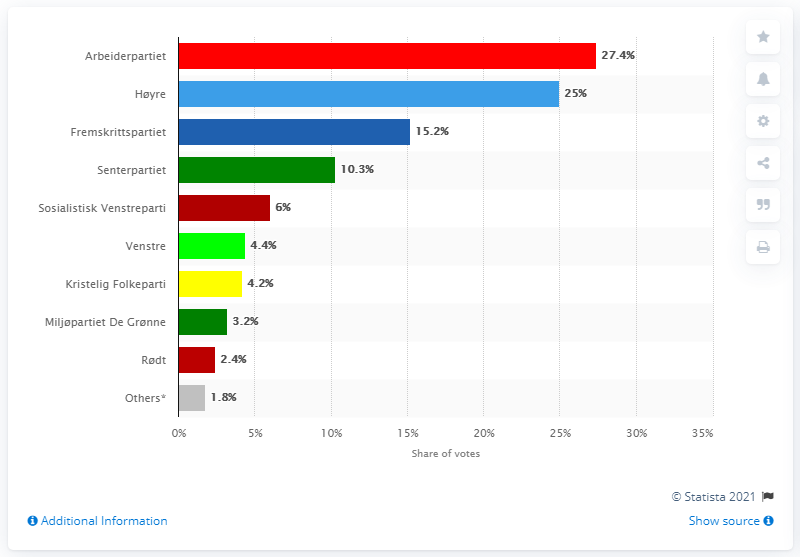Point out several critical features in this image. Fremskrittspartiet received 15.2% of the total votes cast in the most recent election. The Arbeiderpartiet received the largest percentage of votes in the parliament, with 27 percent of the total votes. 